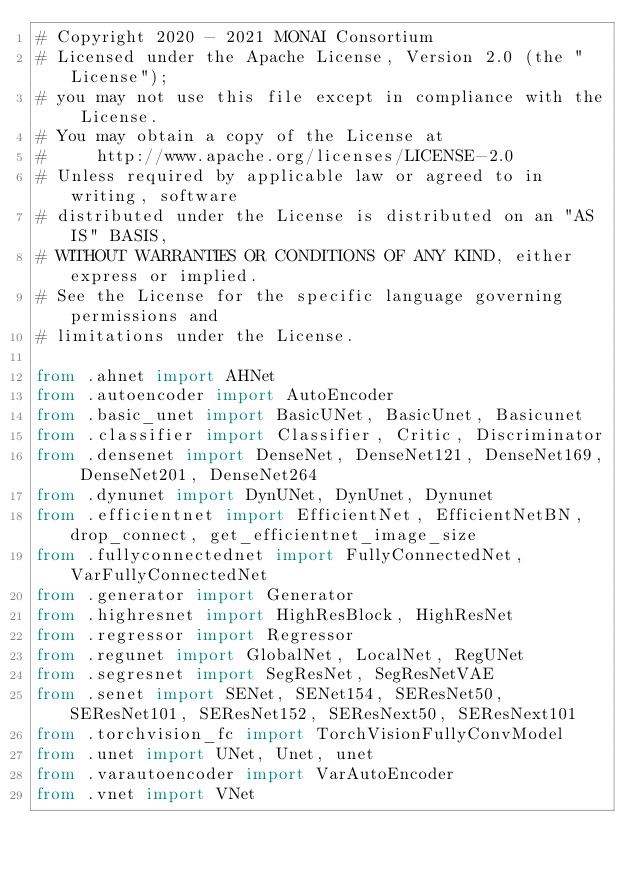Convert code to text. <code><loc_0><loc_0><loc_500><loc_500><_Python_># Copyright 2020 - 2021 MONAI Consortium
# Licensed under the Apache License, Version 2.0 (the "License");
# you may not use this file except in compliance with the License.
# You may obtain a copy of the License at
#     http://www.apache.org/licenses/LICENSE-2.0
# Unless required by applicable law or agreed to in writing, software
# distributed under the License is distributed on an "AS IS" BASIS,
# WITHOUT WARRANTIES OR CONDITIONS OF ANY KIND, either express or implied.
# See the License for the specific language governing permissions and
# limitations under the License.

from .ahnet import AHNet
from .autoencoder import AutoEncoder
from .basic_unet import BasicUNet, BasicUnet, Basicunet
from .classifier import Classifier, Critic, Discriminator
from .densenet import DenseNet, DenseNet121, DenseNet169, DenseNet201, DenseNet264
from .dynunet import DynUNet, DynUnet, Dynunet
from .efficientnet import EfficientNet, EfficientNetBN, drop_connect, get_efficientnet_image_size
from .fullyconnectednet import FullyConnectedNet, VarFullyConnectedNet
from .generator import Generator
from .highresnet import HighResBlock, HighResNet
from .regressor import Regressor
from .regunet import GlobalNet, LocalNet, RegUNet
from .segresnet import SegResNet, SegResNetVAE
from .senet import SENet, SENet154, SEResNet50, SEResNet101, SEResNet152, SEResNext50, SEResNext101
from .torchvision_fc import TorchVisionFullyConvModel
from .unet import UNet, Unet, unet
from .varautoencoder import VarAutoEncoder
from .vnet import VNet
</code> 